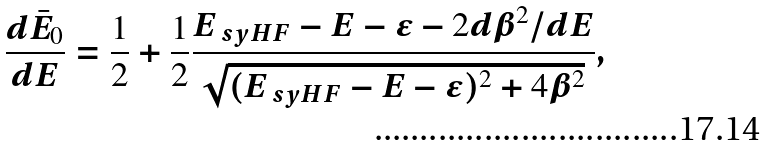<formula> <loc_0><loc_0><loc_500><loc_500>\frac { d \bar { E } _ { 0 } } { d E } = \frac { 1 } { 2 } + \frac { 1 } { 2 } \frac { E _ { \ s y { H F } } - E - \epsilon - 2 d \beta ^ { 2 } / d E } { \sqrt { ( E _ { \ s y { H F } } - E - \epsilon ) ^ { 2 } + 4 \beta ^ { 2 } } } ,</formula> 